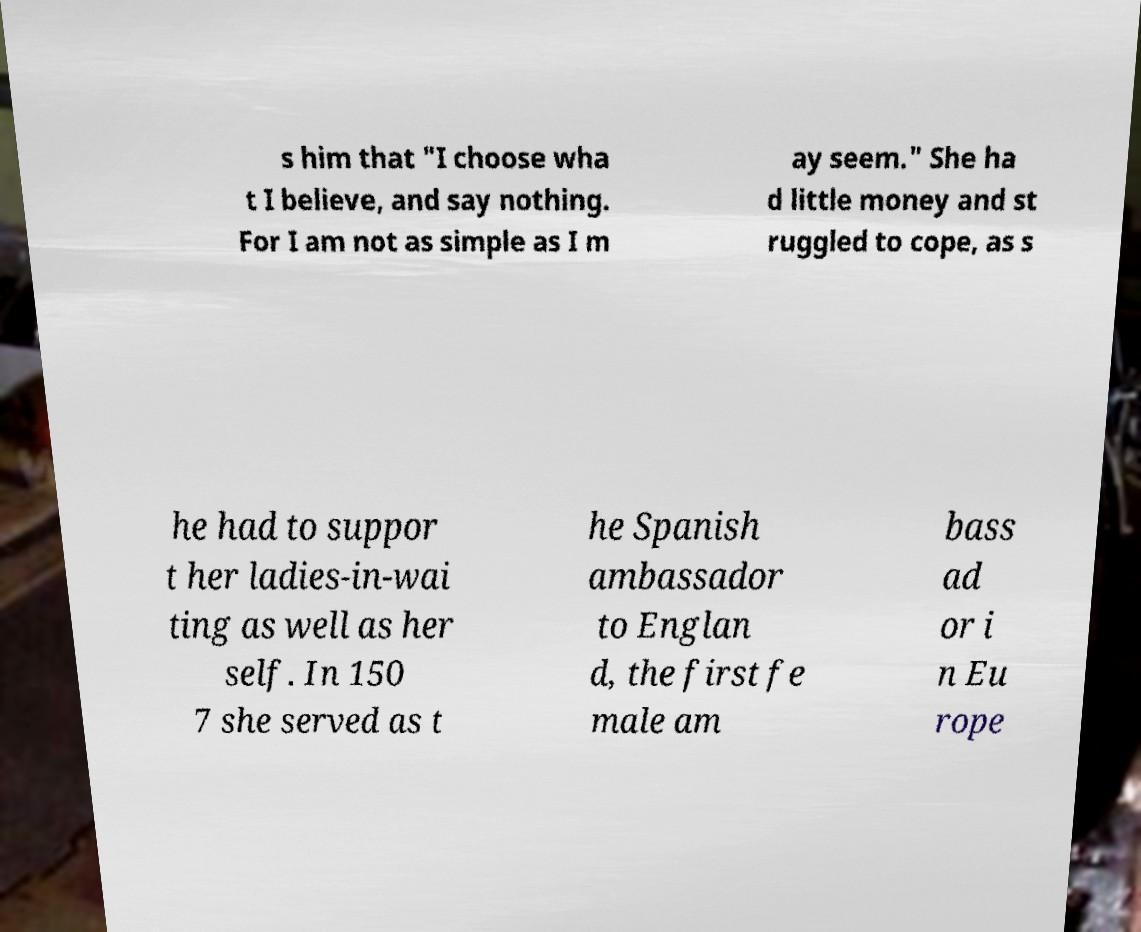Could you extract and type out the text from this image? s him that "I choose wha t I believe, and say nothing. For I am not as simple as I m ay seem." She ha d little money and st ruggled to cope, as s he had to suppor t her ladies-in-wai ting as well as her self. In 150 7 she served as t he Spanish ambassador to Englan d, the first fe male am bass ad or i n Eu rope 